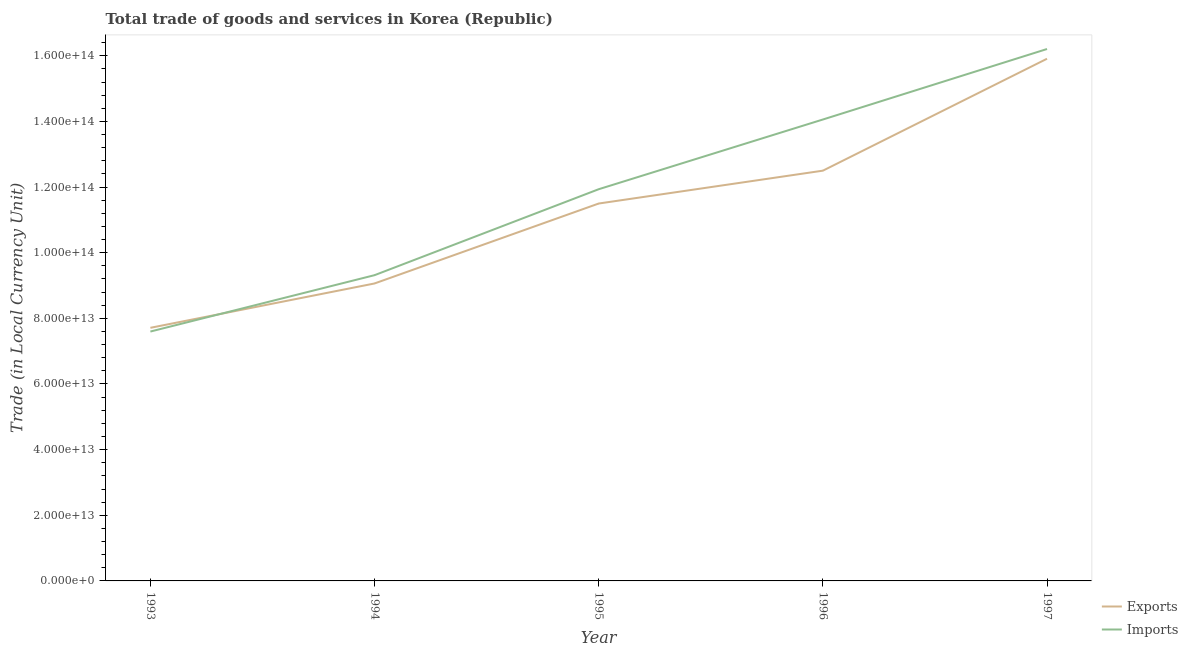Is the number of lines equal to the number of legend labels?
Your answer should be very brief. Yes. What is the imports of goods and services in 1995?
Your answer should be compact. 1.19e+14. Across all years, what is the maximum imports of goods and services?
Make the answer very short. 1.62e+14. Across all years, what is the minimum export of goods and services?
Make the answer very short. 7.71e+13. In which year was the export of goods and services minimum?
Your answer should be compact. 1993. What is the total export of goods and services in the graph?
Provide a succinct answer. 5.67e+14. What is the difference between the export of goods and services in 1993 and that in 1994?
Keep it short and to the point. -1.35e+13. What is the difference between the imports of goods and services in 1996 and the export of goods and services in 1997?
Give a very brief answer. -1.85e+13. What is the average imports of goods and services per year?
Ensure brevity in your answer.  1.18e+14. In the year 1994, what is the difference between the export of goods and services and imports of goods and services?
Make the answer very short. -2.53e+12. What is the ratio of the export of goods and services in 1993 to that in 1995?
Your response must be concise. 0.67. Is the export of goods and services in 1994 less than that in 1995?
Your answer should be very brief. Yes. What is the difference between the highest and the second highest export of goods and services?
Make the answer very short. 3.41e+13. What is the difference between the highest and the lowest export of goods and services?
Offer a very short reply. 8.20e+13. In how many years, is the export of goods and services greater than the average export of goods and services taken over all years?
Offer a very short reply. 3. Does the imports of goods and services monotonically increase over the years?
Keep it short and to the point. Yes. Is the export of goods and services strictly greater than the imports of goods and services over the years?
Your response must be concise. No. Is the imports of goods and services strictly less than the export of goods and services over the years?
Your answer should be very brief. No. What is the difference between two consecutive major ticks on the Y-axis?
Your response must be concise. 2.00e+13. Does the graph contain grids?
Your answer should be compact. No. Where does the legend appear in the graph?
Provide a short and direct response. Bottom right. How many legend labels are there?
Make the answer very short. 2. What is the title of the graph?
Make the answer very short. Total trade of goods and services in Korea (Republic). Does "Grants" appear as one of the legend labels in the graph?
Offer a very short reply. No. What is the label or title of the X-axis?
Your answer should be compact. Year. What is the label or title of the Y-axis?
Ensure brevity in your answer.  Trade (in Local Currency Unit). What is the Trade (in Local Currency Unit) of Exports in 1993?
Your response must be concise. 7.71e+13. What is the Trade (in Local Currency Unit) in Imports in 1993?
Offer a very short reply. 7.60e+13. What is the Trade (in Local Currency Unit) in Exports in 1994?
Offer a very short reply. 9.06e+13. What is the Trade (in Local Currency Unit) of Imports in 1994?
Your response must be concise. 9.31e+13. What is the Trade (in Local Currency Unit) of Exports in 1995?
Your response must be concise. 1.15e+14. What is the Trade (in Local Currency Unit) of Imports in 1995?
Your answer should be compact. 1.19e+14. What is the Trade (in Local Currency Unit) in Exports in 1996?
Offer a very short reply. 1.25e+14. What is the Trade (in Local Currency Unit) in Imports in 1996?
Provide a short and direct response. 1.41e+14. What is the Trade (in Local Currency Unit) in Exports in 1997?
Offer a terse response. 1.59e+14. What is the Trade (in Local Currency Unit) of Imports in 1997?
Provide a short and direct response. 1.62e+14. Across all years, what is the maximum Trade (in Local Currency Unit) in Exports?
Provide a short and direct response. 1.59e+14. Across all years, what is the maximum Trade (in Local Currency Unit) of Imports?
Your response must be concise. 1.62e+14. Across all years, what is the minimum Trade (in Local Currency Unit) in Exports?
Ensure brevity in your answer.  7.71e+13. Across all years, what is the minimum Trade (in Local Currency Unit) of Imports?
Your answer should be compact. 7.60e+13. What is the total Trade (in Local Currency Unit) in Exports in the graph?
Provide a succinct answer. 5.67e+14. What is the total Trade (in Local Currency Unit) in Imports in the graph?
Offer a terse response. 5.91e+14. What is the difference between the Trade (in Local Currency Unit) of Exports in 1993 and that in 1994?
Give a very brief answer. -1.35e+13. What is the difference between the Trade (in Local Currency Unit) of Imports in 1993 and that in 1994?
Your answer should be compact. -1.72e+13. What is the difference between the Trade (in Local Currency Unit) in Exports in 1993 and that in 1995?
Offer a very short reply. -3.79e+13. What is the difference between the Trade (in Local Currency Unit) of Imports in 1993 and that in 1995?
Your answer should be compact. -4.34e+13. What is the difference between the Trade (in Local Currency Unit) in Exports in 1993 and that in 1996?
Ensure brevity in your answer.  -4.79e+13. What is the difference between the Trade (in Local Currency Unit) of Imports in 1993 and that in 1996?
Offer a terse response. -6.46e+13. What is the difference between the Trade (in Local Currency Unit) in Exports in 1993 and that in 1997?
Offer a very short reply. -8.20e+13. What is the difference between the Trade (in Local Currency Unit) of Imports in 1993 and that in 1997?
Your answer should be very brief. -8.61e+13. What is the difference between the Trade (in Local Currency Unit) of Exports in 1994 and that in 1995?
Provide a short and direct response. -2.44e+13. What is the difference between the Trade (in Local Currency Unit) of Imports in 1994 and that in 1995?
Keep it short and to the point. -2.62e+13. What is the difference between the Trade (in Local Currency Unit) of Exports in 1994 and that in 1996?
Your response must be concise. -3.44e+13. What is the difference between the Trade (in Local Currency Unit) in Imports in 1994 and that in 1996?
Provide a succinct answer. -4.74e+13. What is the difference between the Trade (in Local Currency Unit) in Exports in 1994 and that in 1997?
Give a very brief answer. -6.85e+13. What is the difference between the Trade (in Local Currency Unit) in Imports in 1994 and that in 1997?
Provide a short and direct response. -6.89e+13. What is the difference between the Trade (in Local Currency Unit) in Exports in 1995 and that in 1996?
Offer a very short reply. -1.00e+13. What is the difference between the Trade (in Local Currency Unit) in Imports in 1995 and that in 1996?
Your answer should be very brief. -2.12e+13. What is the difference between the Trade (in Local Currency Unit) of Exports in 1995 and that in 1997?
Make the answer very short. -4.41e+13. What is the difference between the Trade (in Local Currency Unit) of Imports in 1995 and that in 1997?
Your answer should be very brief. -4.27e+13. What is the difference between the Trade (in Local Currency Unit) in Exports in 1996 and that in 1997?
Keep it short and to the point. -3.41e+13. What is the difference between the Trade (in Local Currency Unit) in Imports in 1996 and that in 1997?
Your answer should be very brief. -2.15e+13. What is the difference between the Trade (in Local Currency Unit) of Exports in 1993 and the Trade (in Local Currency Unit) of Imports in 1994?
Offer a terse response. -1.60e+13. What is the difference between the Trade (in Local Currency Unit) in Exports in 1993 and the Trade (in Local Currency Unit) in Imports in 1995?
Make the answer very short. -4.22e+13. What is the difference between the Trade (in Local Currency Unit) in Exports in 1993 and the Trade (in Local Currency Unit) in Imports in 1996?
Ensure brevity in your answer.  -6.35e+13. What is the difference between the Trade (in Local Currency Unit) of Exports in 1993 and the Trade (in Local Currency Unit) of Imports in 1997?
Offer a very short reply. -8.49e+13. What is the difference between the Trade (in Local Currency Unit) of Exports in 1994 and the Trade (in Local Currency Unit) of Imports in 1995?
Your response must be concise. -2.87e+13. What is the difference between the Trade (in Local Currency Unit) of Exports in 1994 and the Trade (in Local Currency Unit) of Imports in 1996?
Your answer should be compact. -5.00e+13. What is the difference between the Trade (in Local Currency Unit) of Exports in 1994 and the Trade (in Local Currency Unit) of Imports in 1997?
Keep it short and to the point. -7.14e+13. What is the difference between the Trade (in Local Currency Unit) in Exports in 1995 and the Trade (in Local Currency Unit) in Imports in 1996?
Offer a terse response. -2.56e+13. What is the difference between the Trade (in Local Currency Unit) in Exports in 1995 and the Trade (in Local Currency Unit) in Imports in 1997?
Provide a succinct answer. -4.71e+13. What is the difference between the Trade (in Local Currency Unit) in Exports in 1996 and the Trade (in Local Currency Unit) in Imports in 1997?
Offer a very short reply. -3.71e+13. What is the average Trade (in Local Currency Unit) of Exports per year?
Ensure brevity in your answer.  1.13e+14. What is the average Trade (in Local Currency Unit) of Imports per year?
Provide a succinct answer. 1.18e+14. In the year 1993, what is the difference between the Trade (in Local Currency Unit) in Exports and Trade (in Local Currency Unit) in Imports?
Provide a succinct answer. 1.14e+12. In the year 1994, what is the difference between the Trade (in Local Currency Unit) of Exports and Trade (in Local Currency Unit) of Imports?
Make the answer very short. -2.53e+12. In the year 1995, what is the difference between the Trade (in Local Currency Unit) of Exports and Trade (in Local Currency Unit) of Imports?
Your response must be concise. -4.36e+12. In the year 1996, what is the difference between the Trade (in Local Currency Unit) in Exports and Trade (in Local Currency Unit) in Imports?
Give a very brief answer. -1.56e+13. In the year 1997, what is the difference between the Trade (in Local Currency Unit) of Exports and Trade (in Local Currency Unit) of Imports?
Offer a terse response. -2.96e+12. What is the ratio of the Trade (in Local Currency Unit) in Exports in 1993 to that in 1994?
Offer a terse response. 0.85. What is the ratio of the Trade (in Local Currency Unit) of Imports in 1993 to that in 1994?
Your response must be concise. 0.82. What is the ratio of the Trade (in Local Currency Unit) of Exports in 1993 to that in 1995?
Your response must be concise. 0.67. What is the ratio of the Trade (in Local Currency Unit) of Imports in 1993 to that in 1995?
Provide a short and direct response. 0.64. What is the ratio of the Trade (in Local Currency Unit) of Exports in 1993 to that in 1996?
Ensure brevity in your answer.  0.62. What is the ratio of the Trade (in Local Currency Unit) in Imports in 1993 to that in 1996?
Offer a very short reply. 0.54. What is the ratio of the Trade (in Local Currency Unit) of Exports in 1993 to that in 1997?
Keep it short and to the point. 0.48. What is the ratio of the Trade (in Local Currency Unit) in Imports in 1993 to that in 1997?
Provide a succinct answer. 0.47. What is the ratio of the Trade (in Local Currency Unit) of Exports in 1994 to that in 1995?
Give a very brief answer. 0.79. What is the ratio of the Trade (in Local Currency Unit) in Imports in 1994 to that in 1995?
Ensure brevity in your answer.  0.78. What is the ratio of the Trade (in Local Currency Unit) in Exports in 1994 to that in 1996?
Offer a terse response. 0.73. What is the ratio of the Trade (in Local Currency Unit) of Imports in 1994 to that in 1996?
Provide a succinct answer. 0.66. What is the ratio of the Trade (in Local Currency Unit) of Exports in 1994 to that in 1997?
Your answer should be very brief. 0.57. What is the ratio of the Trade (in Local Currency Unit) in Imports in 1994 to that in 1997?
Your answer should be compact. 0.57. What is the ratio of the Trade (in Local Currency Unit) in Exports in 1995 to that in 1996?
Your answer should be compact. 0.92. What is the ratio of the Trade (in Local Currency Unit) of Imports in 1995 to that in 1996?
Ensure brevity in your answer.  0.85. What is the ratio of the Trade (in Local Currency Unit) in Exports in 1995 to that in 1997?
Keep it short and to the point. 0.72. What is the ratio of the Trade (in Local Currency Unit) of Imports in 1995 to that in 1997?
Your answer should be very brief. 0.74. What is the ratio of the Trade (in Local Currency Unit) of Exports in 1996 to that in 1997?
Provide a short and direct response. 0.79. What is the ratio of the Trade (in Local Currency Unit) of Imports in 1996 to that in 1997?
Provide a succinct answer. 0.87. What is the difference between the highest and the second highest Trade (in Local Currency Unit) of Exports?
Make the answer very short. 3.41e+13. What is the difference between the highest and the second highest Trade (in Local Currency Unit) of Imports?
Make the answer very short. 2.15e+13. What is the difference between the highest and the lowest Trade (in Local Currency Unit) of Exports?
Give a very brief answer. 8.20e+13. What is the difference between the highest and the lowest Trade (in Local Currency Unit) in Imports?
Your response must be concise. 8.61e+13. 